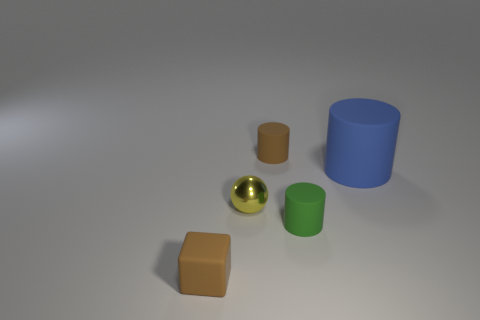Add 4 yellow objects. How many objects exist? 9 Subtract all cylinders. How many objects are left? 2 Add 5 tiny blue rubber spheres. How many tiny blue rubber spheres exist? 5 Subtract 0 yellow blocks. How many objects are left? 5 Subtract all large yellow spheres. Subtract all matte objects. How many objects are left? 1 Add 3 tiny brown matte cylinders. How many tiny brown matte cylinders are left? 4 